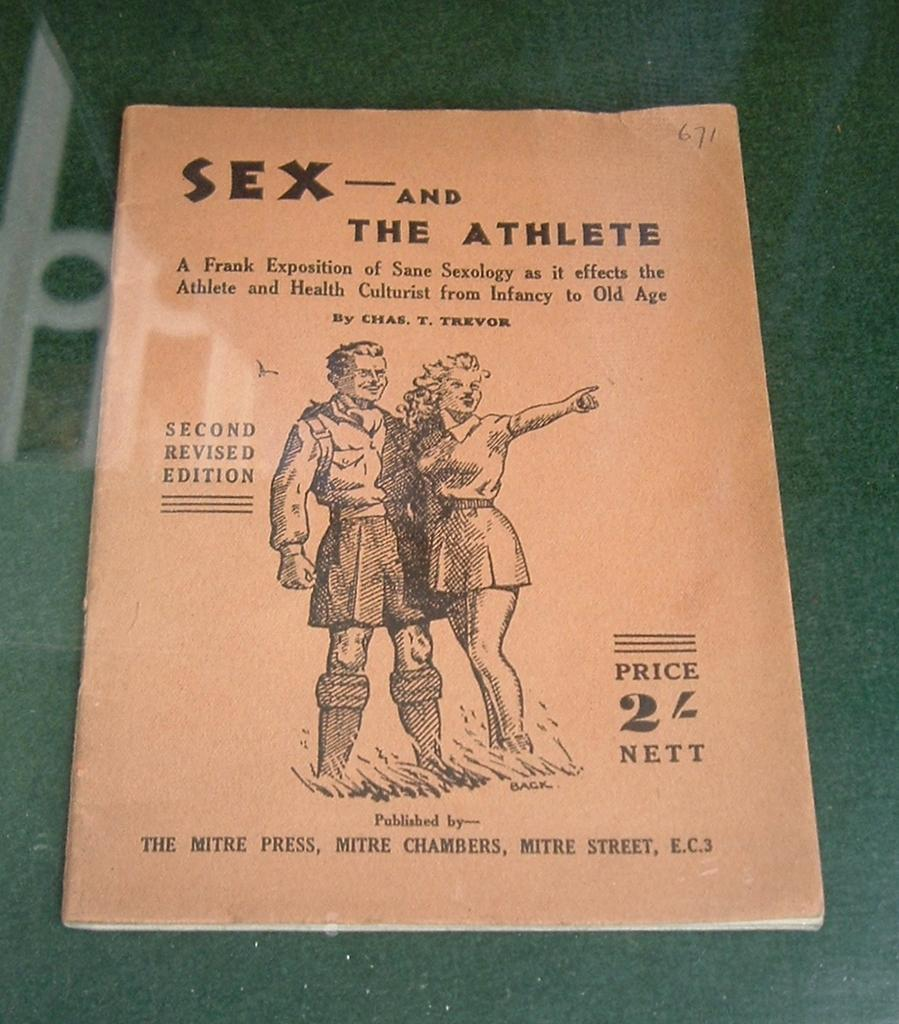What is the main object in the image? There is a book in the image. What is the color of the surface the book is on? The book is on a green surface. What can be seen on the cover page of the book? There are text and images on the cover page of the book. How does the heat affect the soda in the image? There is no soda present in the image, so the effect of heat cannot be determined. 